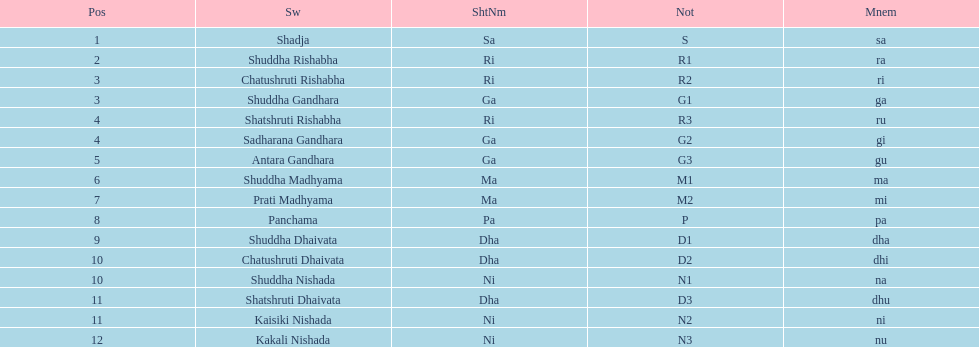Excluding m1, how many representations have "1" in them? 4. 